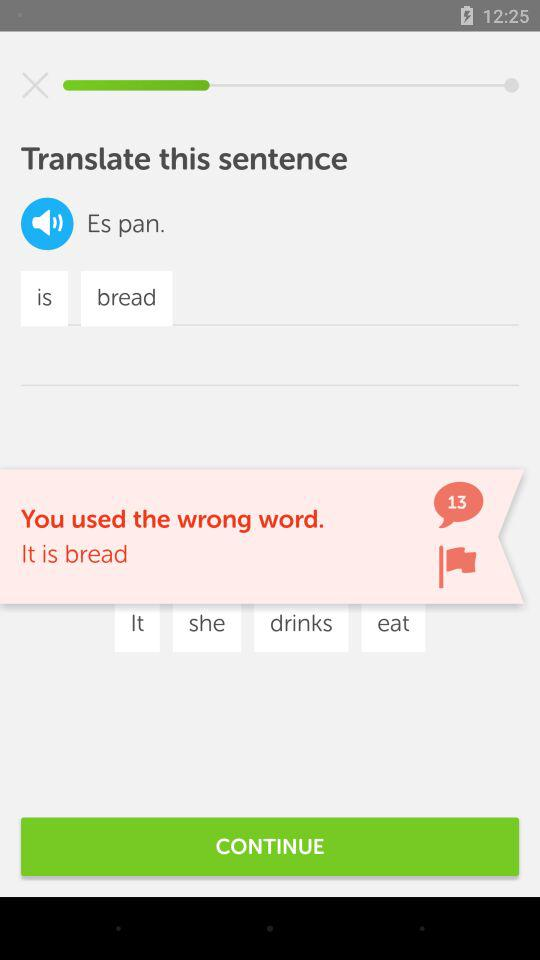How many comments are there? There are 13 comments. 